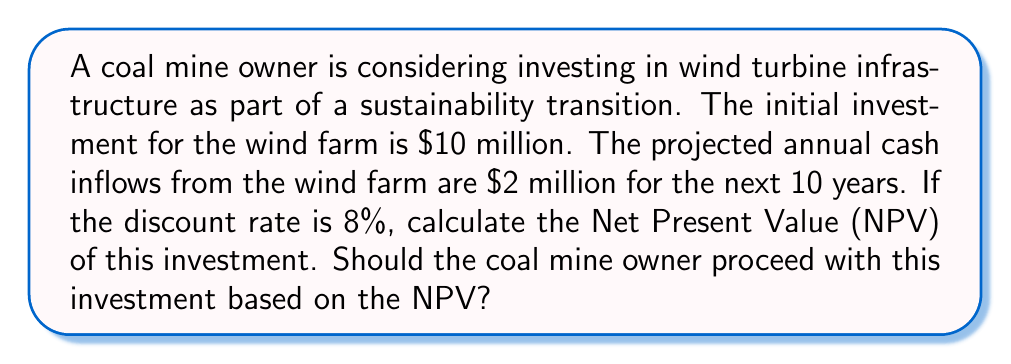Give your solution to this math problem. To calculate the Net Present Value (NPV) of the wind turbine investment, we need to follow these steps:

1. Calculate the present value of all future cash inflows
2. Subtract the initial investment from the sum of present values

The formula for NPV is:

$$NPV = -C_0 + \sum_{t=1}^{n} \frac{C_t}{(1+r)^t}$$

Where:
$C_0$ = Initial investment
$C_t$ = Cash flow at time t
$r$ = Discount rate
$n$ = Number of periods

Let's break it down step by step:

1. Initial investment ($C_0$) = $10 million
2. Annual cash inflow ($C_t$) = $2 million
3. Discount rate ($r$) = 8% = 0.08
4. Number of periods ($n$) = 10 years

Now, let's calculate the present value of each year's cash flow:

Year 1: $\frac{2,000,000}{(1+0.08)^1} = 1,851,851.85$
Year 2: $\frac{2,000,000}{(1+0.08)^2} = 1,714,677.64$
Year 3: $\frac{2,000,000}{(1+0.08)^3} = 1,587,664.48$
...
Year 10: $\frac{2,000,000}{(1+0.08)^{10}} = 925,925.93$

Sum of present values: $13,576,985.27$

Now, we can calculate the NPV:

$$NPV = -10,000,000 + 13,576,985.27 = 3,576,985.27$$

The NPV is positive, which means the investment is expected to be profitable. In general, if the NPV is greater than zero, the investment should be considered.
Answer: The Net Present Value (NPV) of the wind turbine investment is $3,576,985.27. Since the NPV is positive, the coal mine owner should proceed with this investment as it is expected to generate value for the company. 